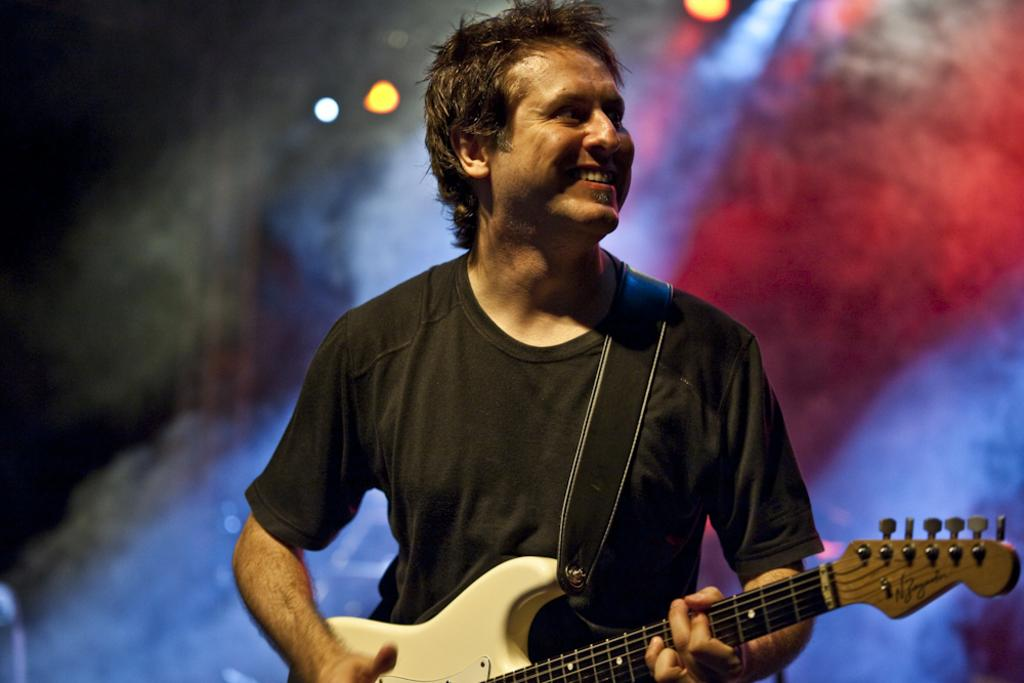Who is the main subject in the image? There is a man in the image. What is the man holding in the image? The man is holding a guitar. What is the man's facial expression in the image? The man is smiling. What can be seen in the background of the image? There are lights visible in the background of the image. How would you describe the background in the image? The background is blurry. What type of flower is the man wearing on his vest in the image? There is no flower or vest present in the image. Is the man part of a band in the image? The image does not provide any information about the man being part of a band. 